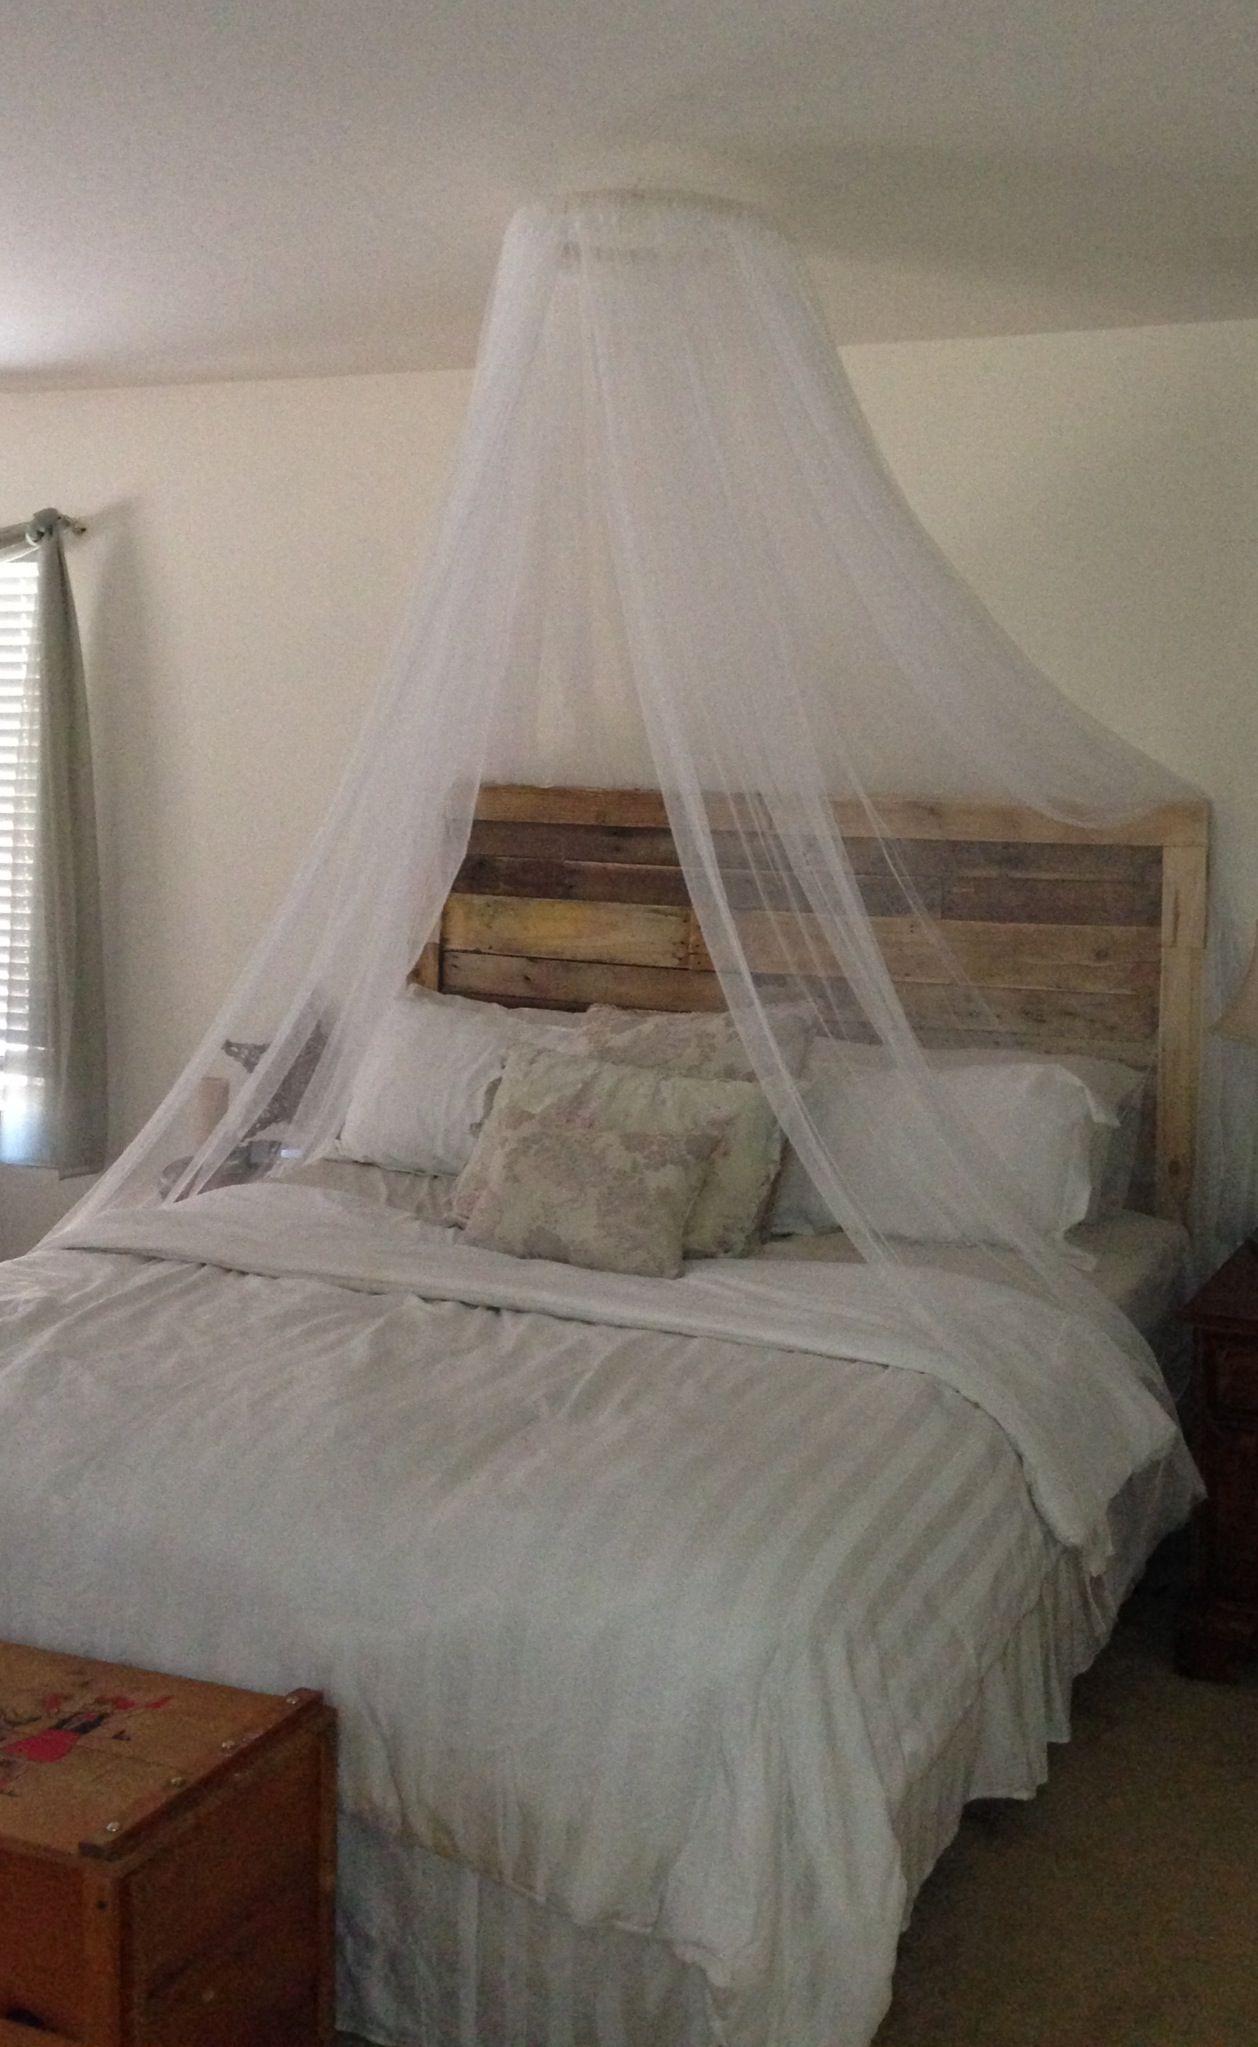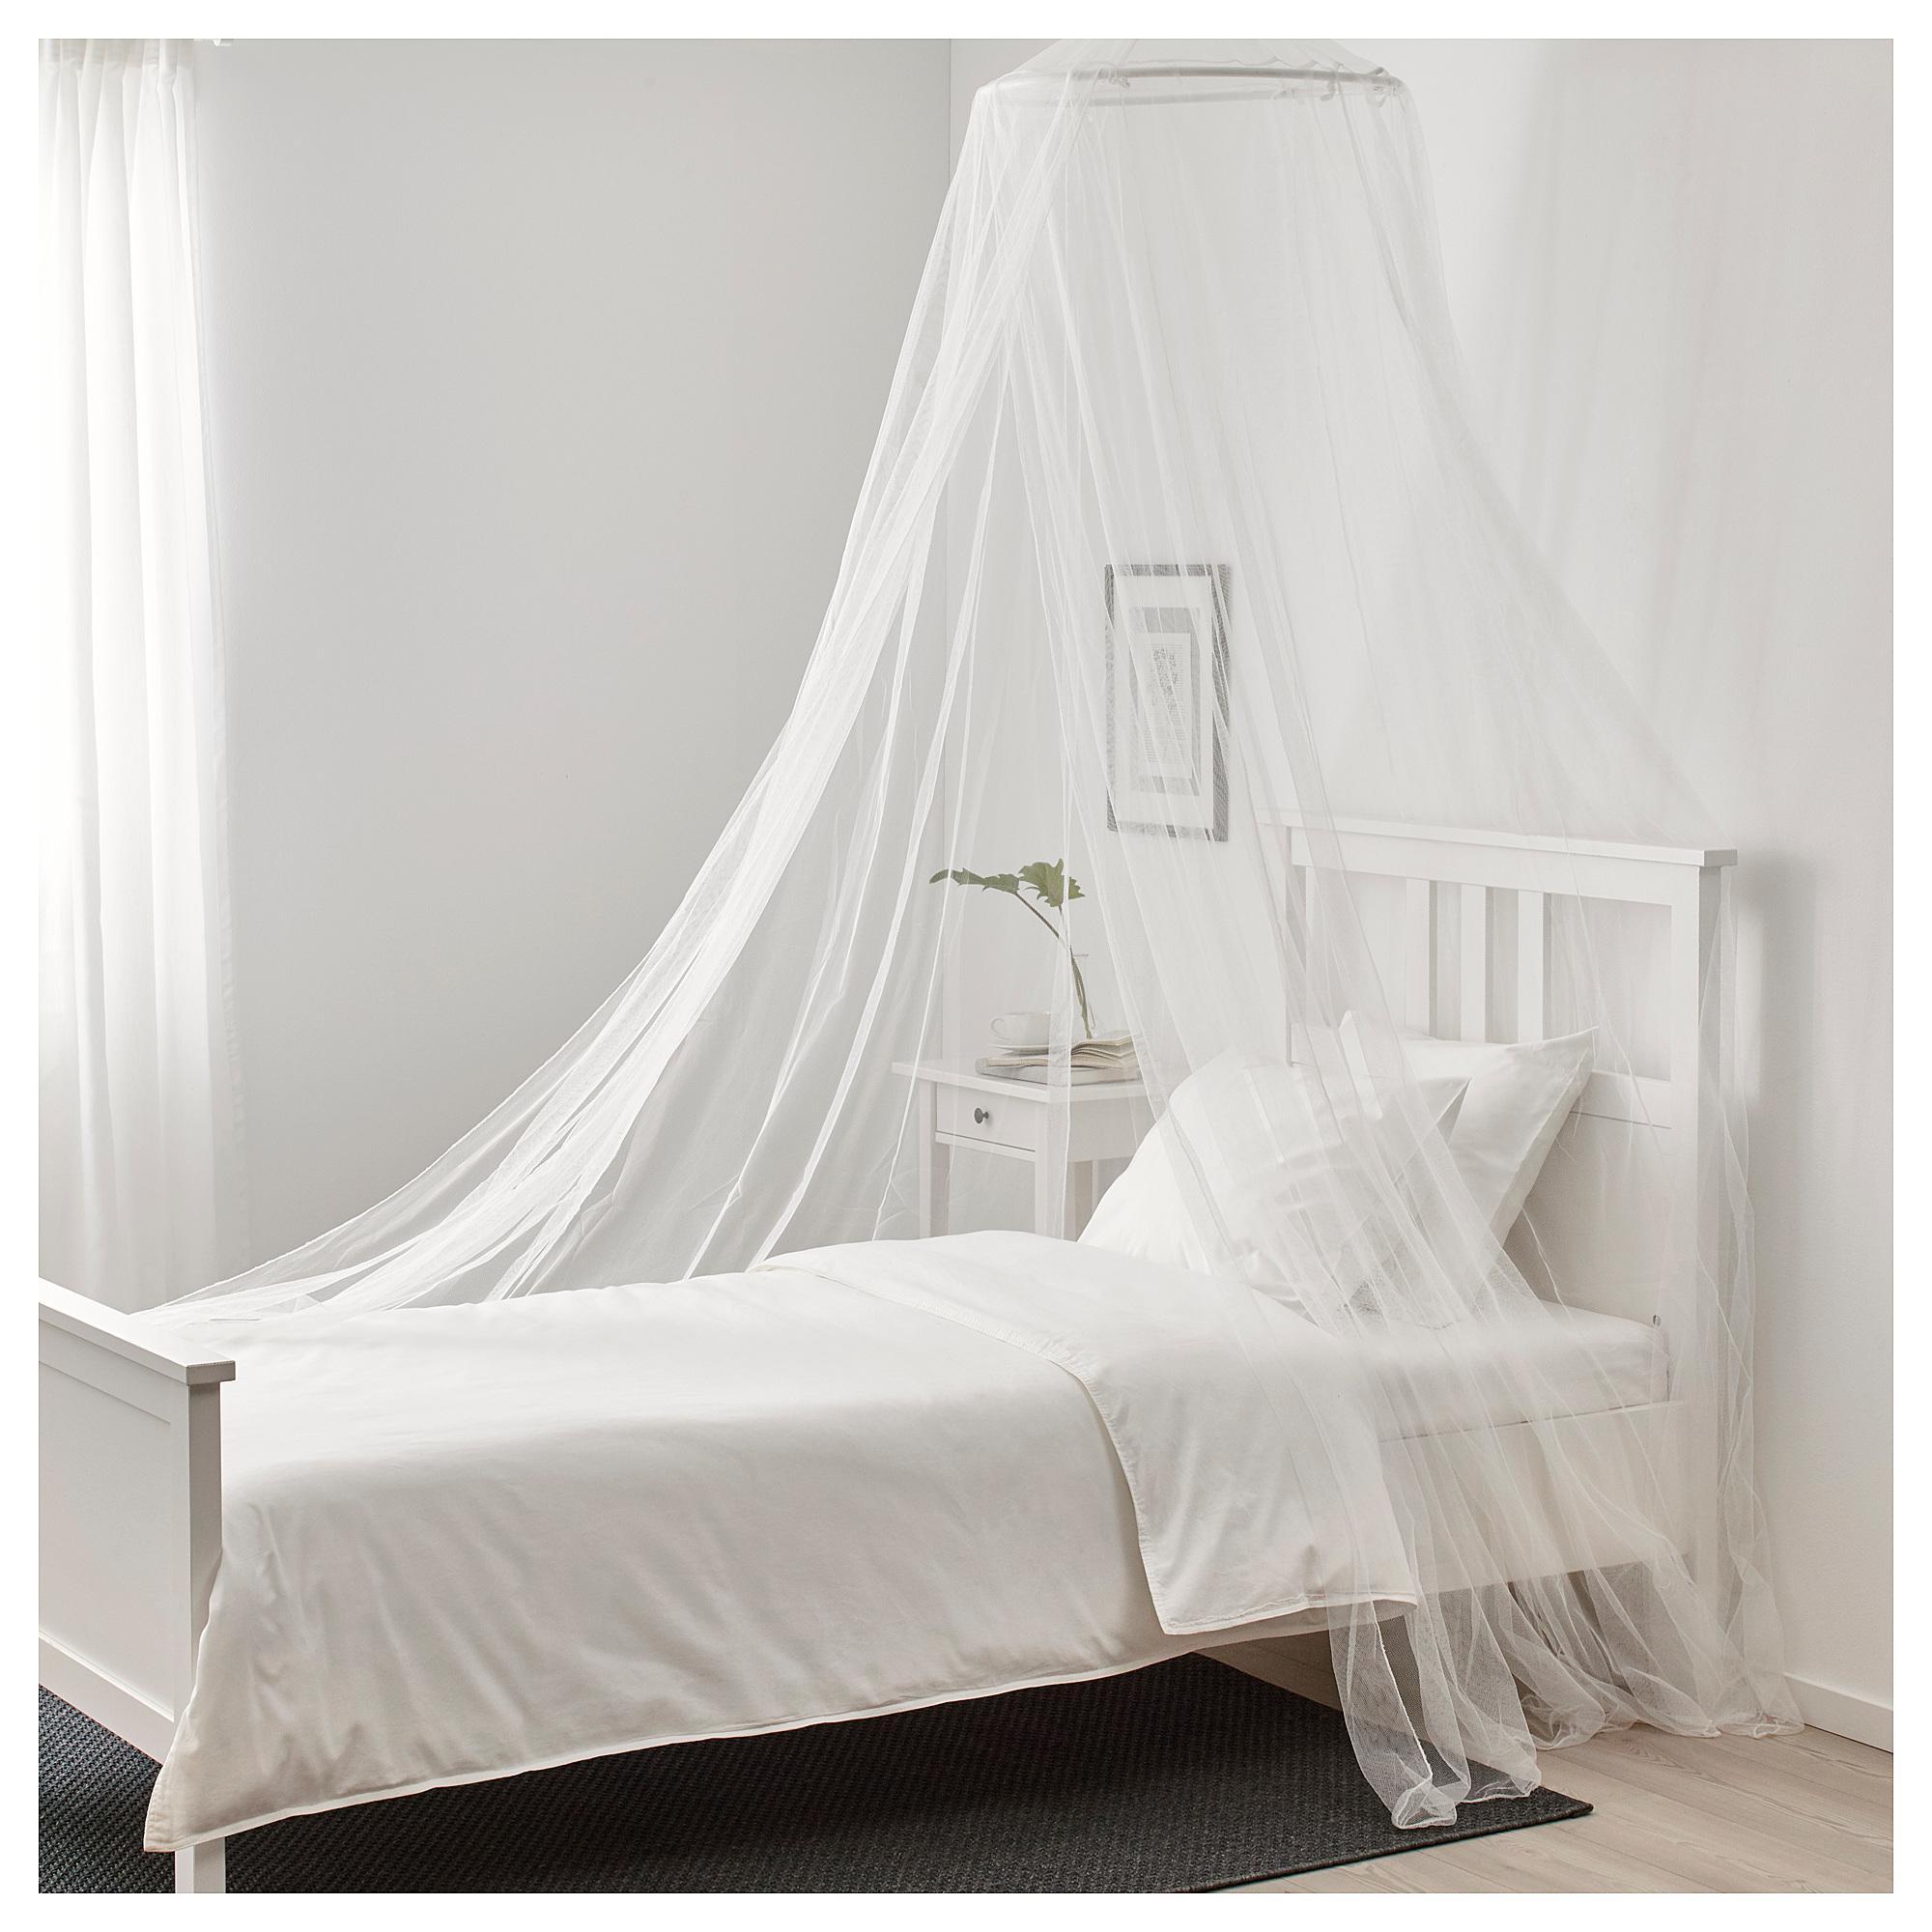The first image is the image on the left, the second image is the image on the right. Assess this claim about the two images: "There are two circle canopies.". Correct or not? Answer yes or no. Yes. The first image is the image on the left, the second image is the image on the right. Given the left and right images, does the statement "In the left image, you can see the entire window; the window top, bottom and both sides are clearly visible." hold true? Answer yes or no. No. 